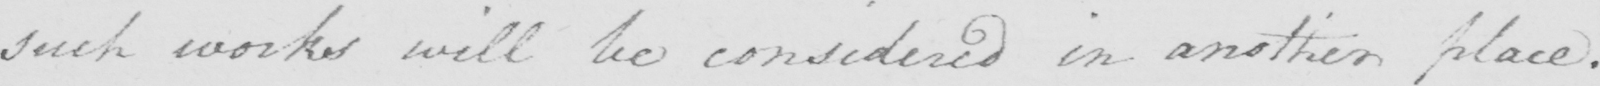Can you tell me what this handwritten text says? such works will be considered in another place . 